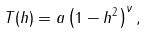Convert formula to latex. <formula><loc_0><loc_0><loc_500><loc_500>T ( h ) = a \left ( 1 - h ^ { 2 } \right ) ^ { \nu } ,</formula> 